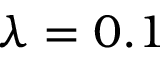Convert formula to latex. <formula><loc_0><loc_0><loc_500><loc_500>\lambda = 0 . 1</formula> 